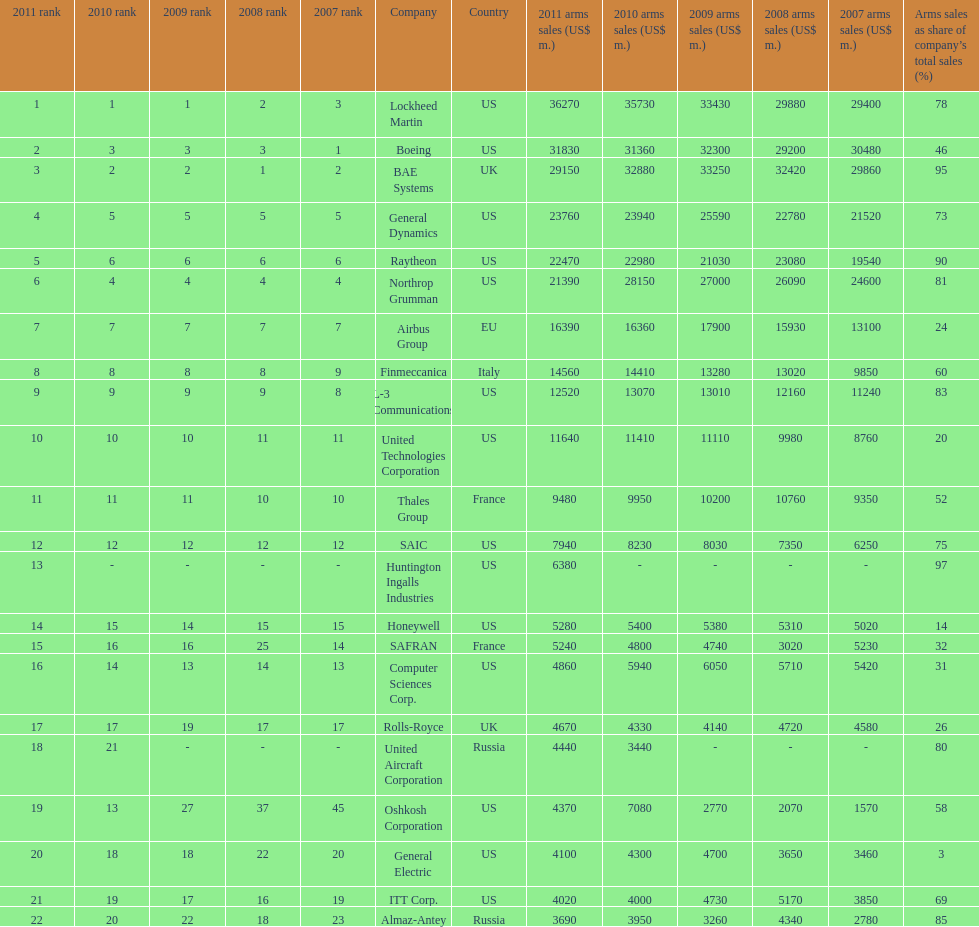How many companies are under the united states? 14. 